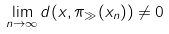<formula> <loc_0><loc_0><loc_500><loc_500>\lim _ { n \to \infty } d ( x , \pi _ { \gg } ( x _ { n } ) ) \neq 0</formula> 